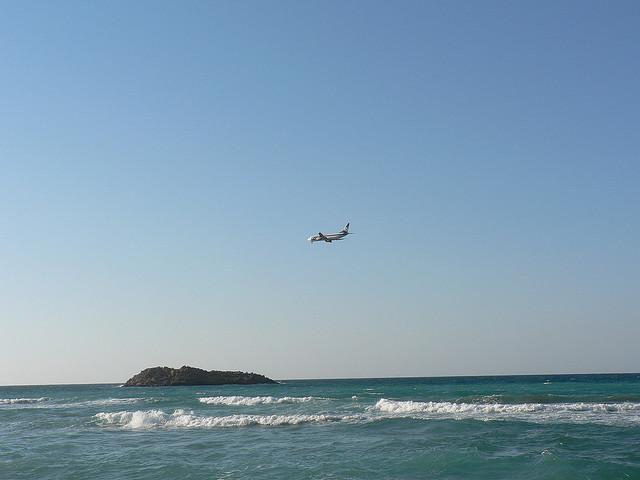What is flying in the air?
Write a very short answer. Plane. Does it take balance to enjoy this sport?
Quick response, please. Yes. Is the plane landing on that island?
Give a very brief answer. No. Where is the helicopter?
Give a very brief answer. No helicopter. What is flying on the distant island?
Concise answer only. Airplane. What is in the air?
Be succinct. Plane. Is it cloudy?
Keep it brief. No. What is this plane about to do?
Write a very short answer. Land. What is the object flying over the sea?
Concise answer only. Plane. 